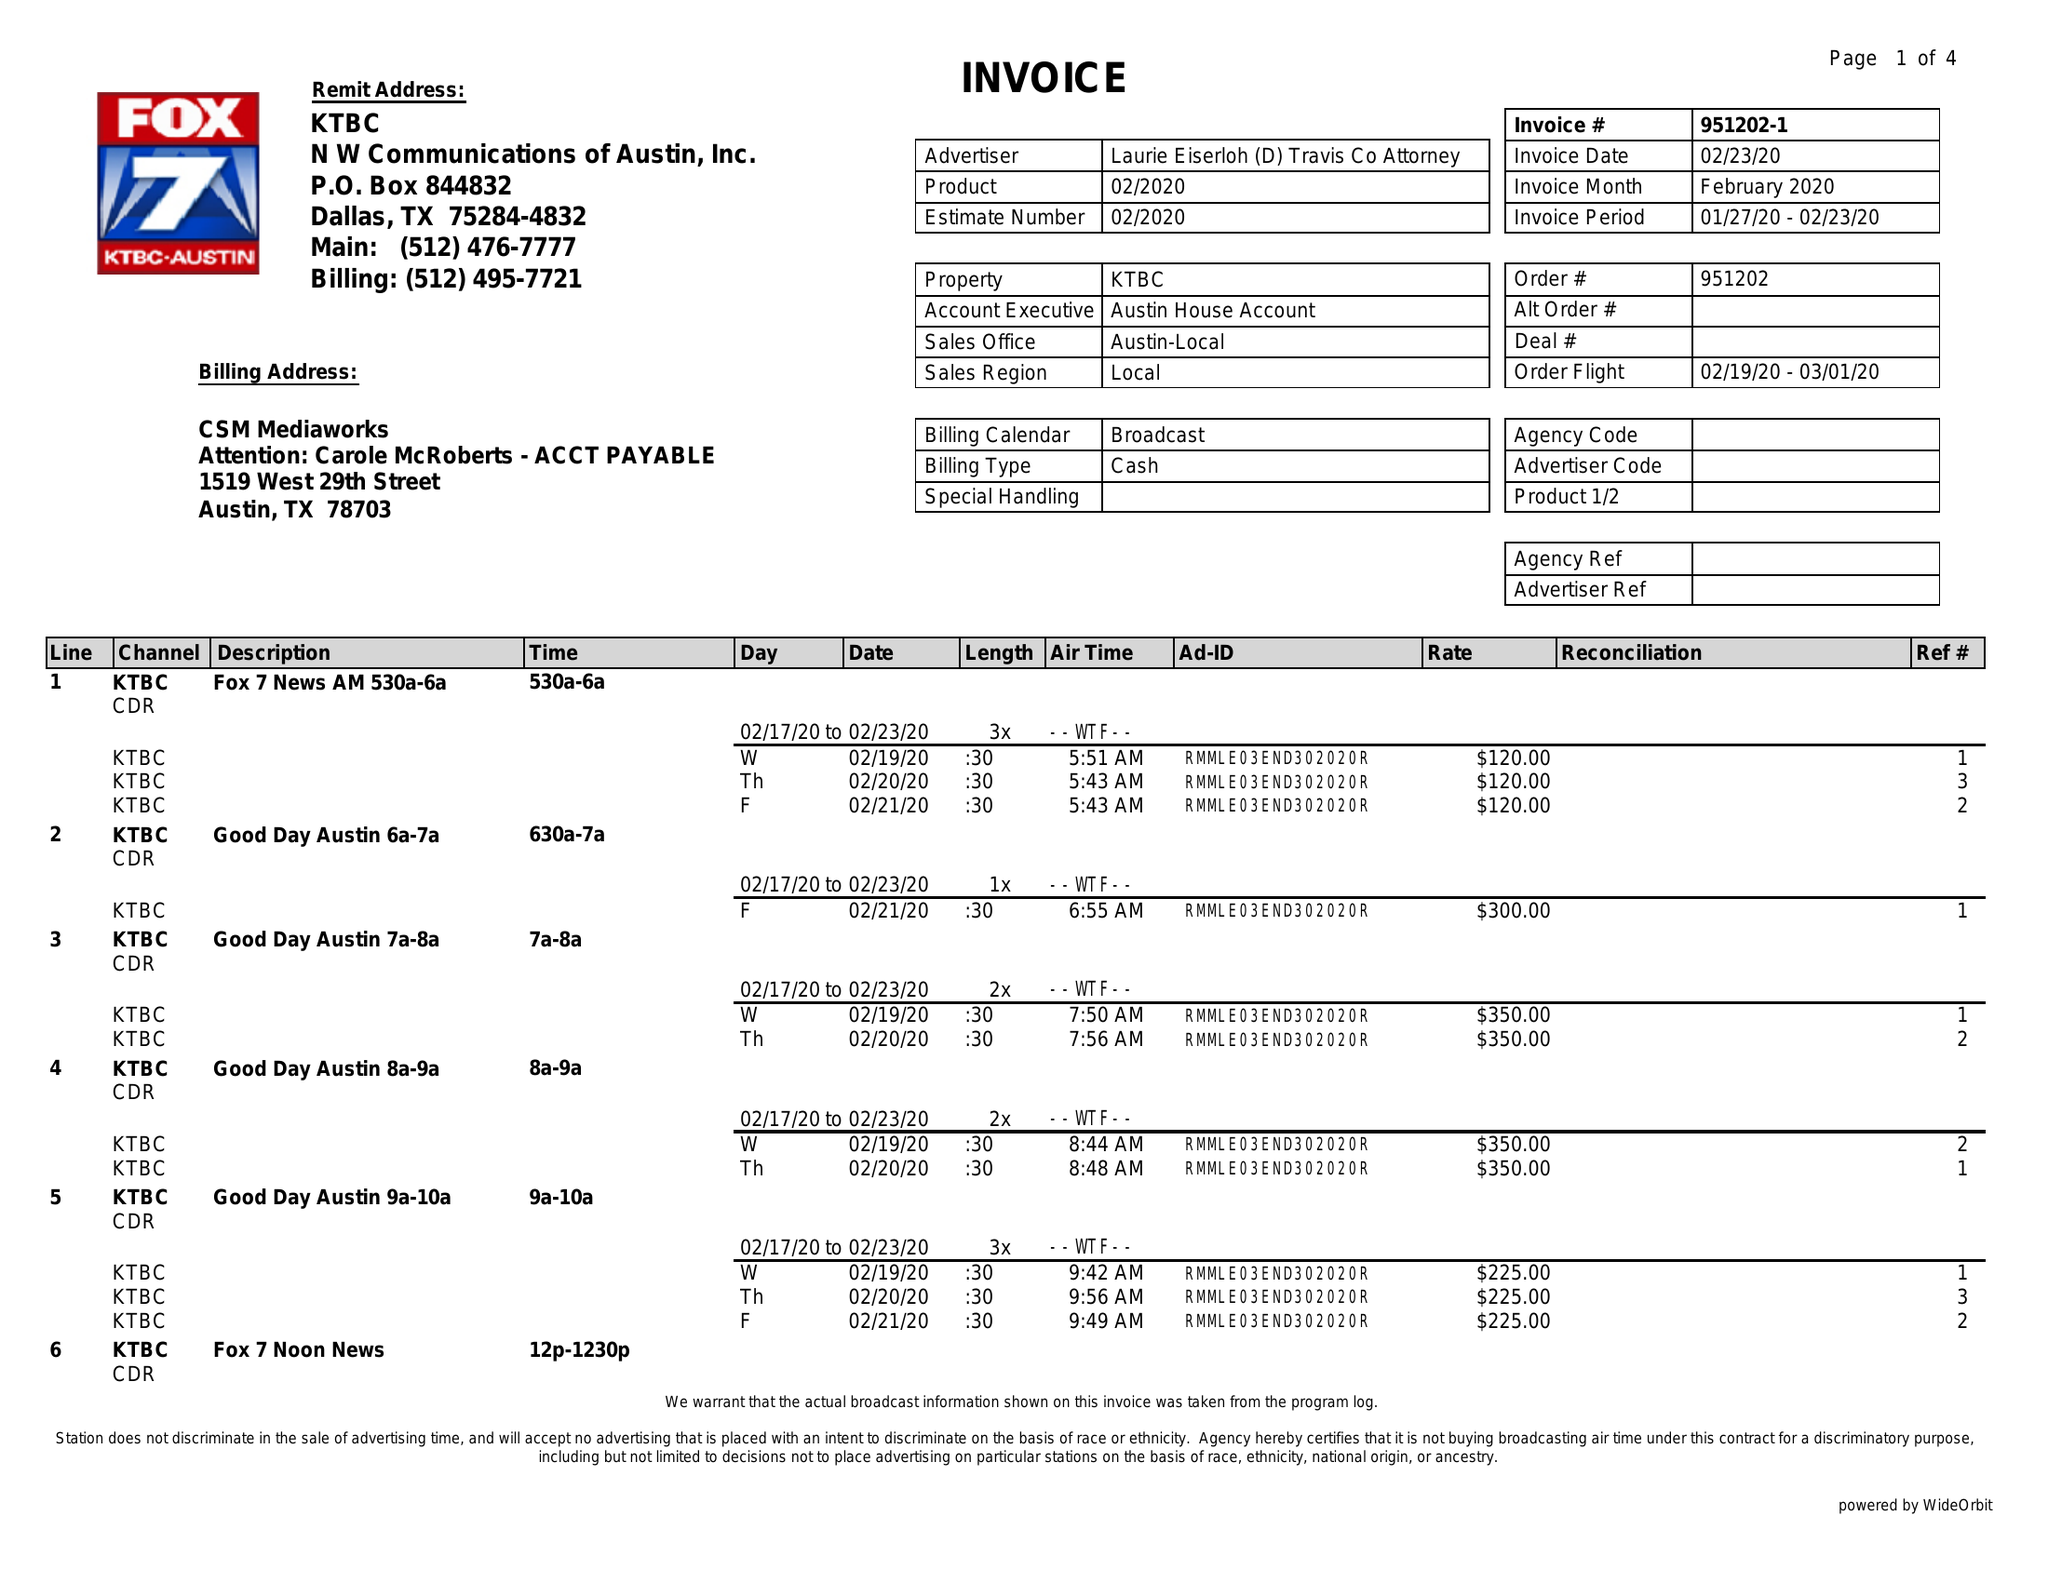What is the value for the contract_num?
Answer the question using a single word or phrase. 951202 